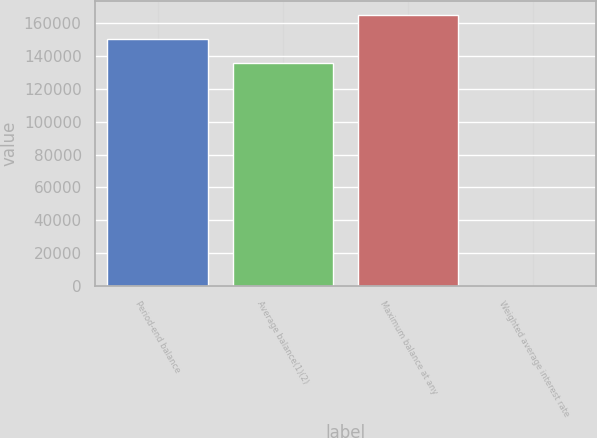Convert chart to OTSL. <chart><loc_0><loc_0><loc_500><loc_500><bar_chart><fcel>Period-end balance<fcel>Average balance(1)(2)<fcel>Maximum balance at any<fcel>Weighted average interest rate<nl><fcel>150719<fcel>136151<fcel>165286<fcel>0.4<nl></chart> 